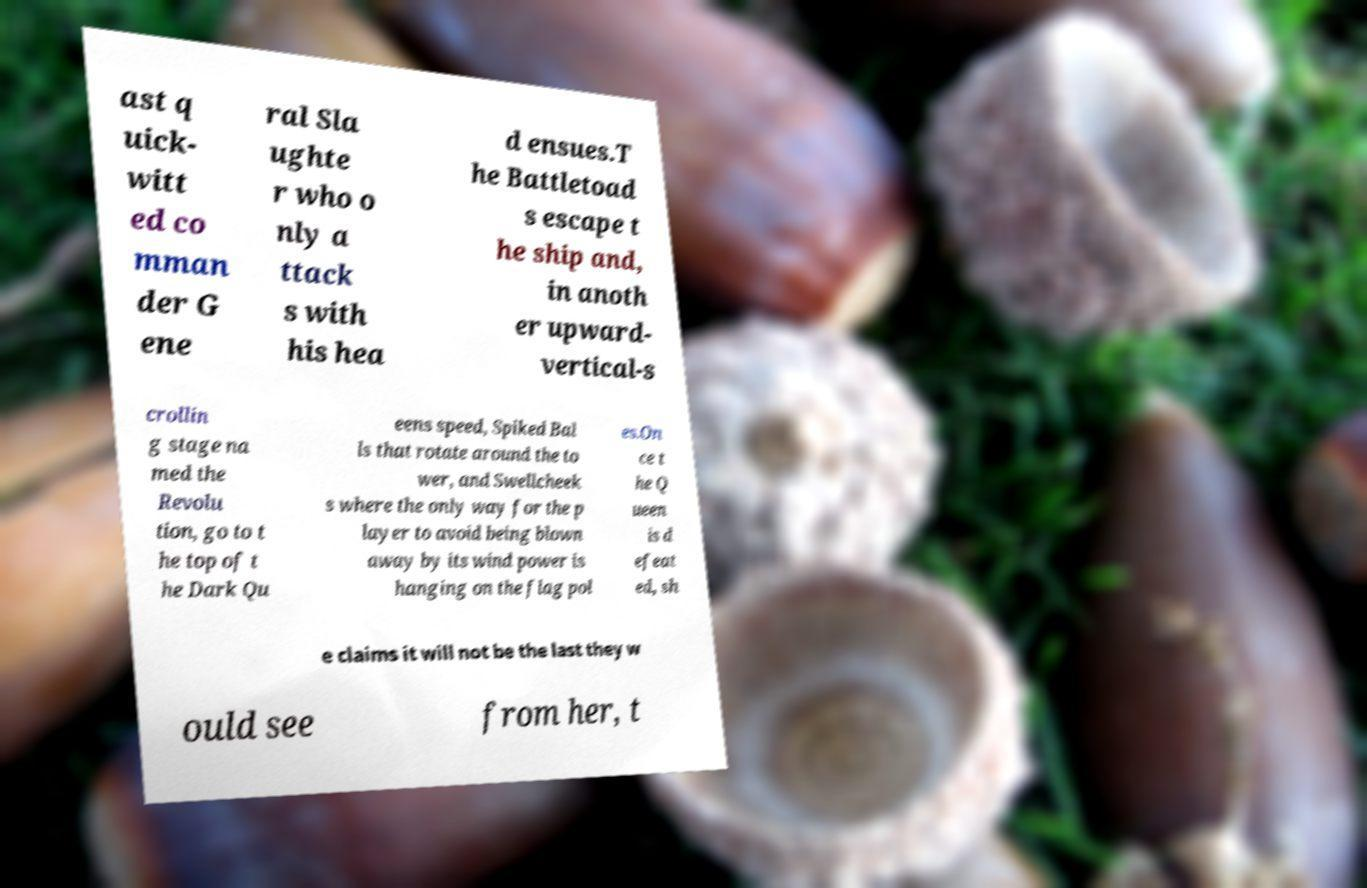For documentation purposes, I need the text within this image transcribed. Could you provide that? ast q uick- witt ed co mman der G ene ral Sla ughte r who o nly a ttack s with his hea d ensues.T he Battletoad s escape t he ship and, in anoth er upward- vertical-s crollin g stage na med the Revolu tion, go to t he top of t he Dark Qu eens speed, Spiked Bal ls that rotate around the to wer, and Swellcheek s where the only way for the p layer to avoid being blown away by its wind power is hanging on the flag pol es.On ce t he Q ueen is d efeat ed, sh e claims it will not be the last they w ould see from her, t 